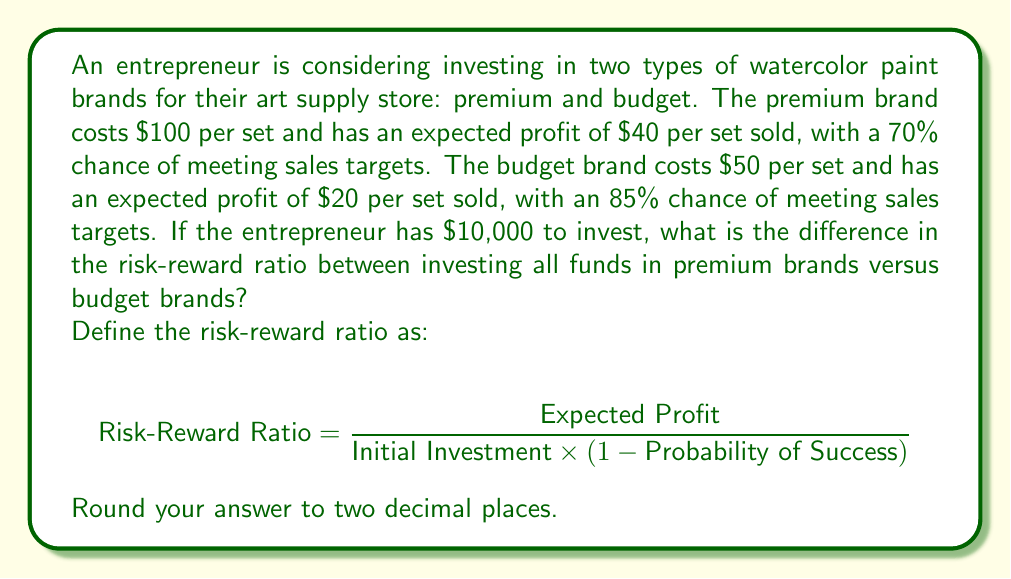Help me with this question. Let's solve this problem step by step:

1. Calculate the number of sets that can be purchased with $10,000:
   - Premium: $10,000 \div $100 = 100 sets
   - Budget: $10,000 \div $50 = 200 sets

2. Calculate the expected profit for each scenario:
   - Premium: $40 \times 100 = $4,000
   - Budget: $20 \times 200 = $4,000

3. Calculate the probability of failure for each brand:
   - Premium: 1 - 0.70 = 0.30
   - Budget: 1 - 0.85 = 0.15

4. Calculate the risk-reward ratio for premium brands:
   $$ \text{RRR}_{\text{premium}} = \frac{4000}{10000 \times 0.30} = \frac{4000}{3000} = 1.33 $$

5. Calculate the risk-reward ratio for budget brands:
   $$ \text{RRR}_{\text{budget}} = \frac{4000}{10000 \times 0.15} = \frac{4000}{1500} = 2.67 $$

6. Calculate the difference between the two ratios:
   $$ \text{Difference} = \text{RRR}_{\text{budget}} - \text{RRR}_{\text{premium}} = 2.67 - 1.33 = 1.34 $$
Answer: 1.34 